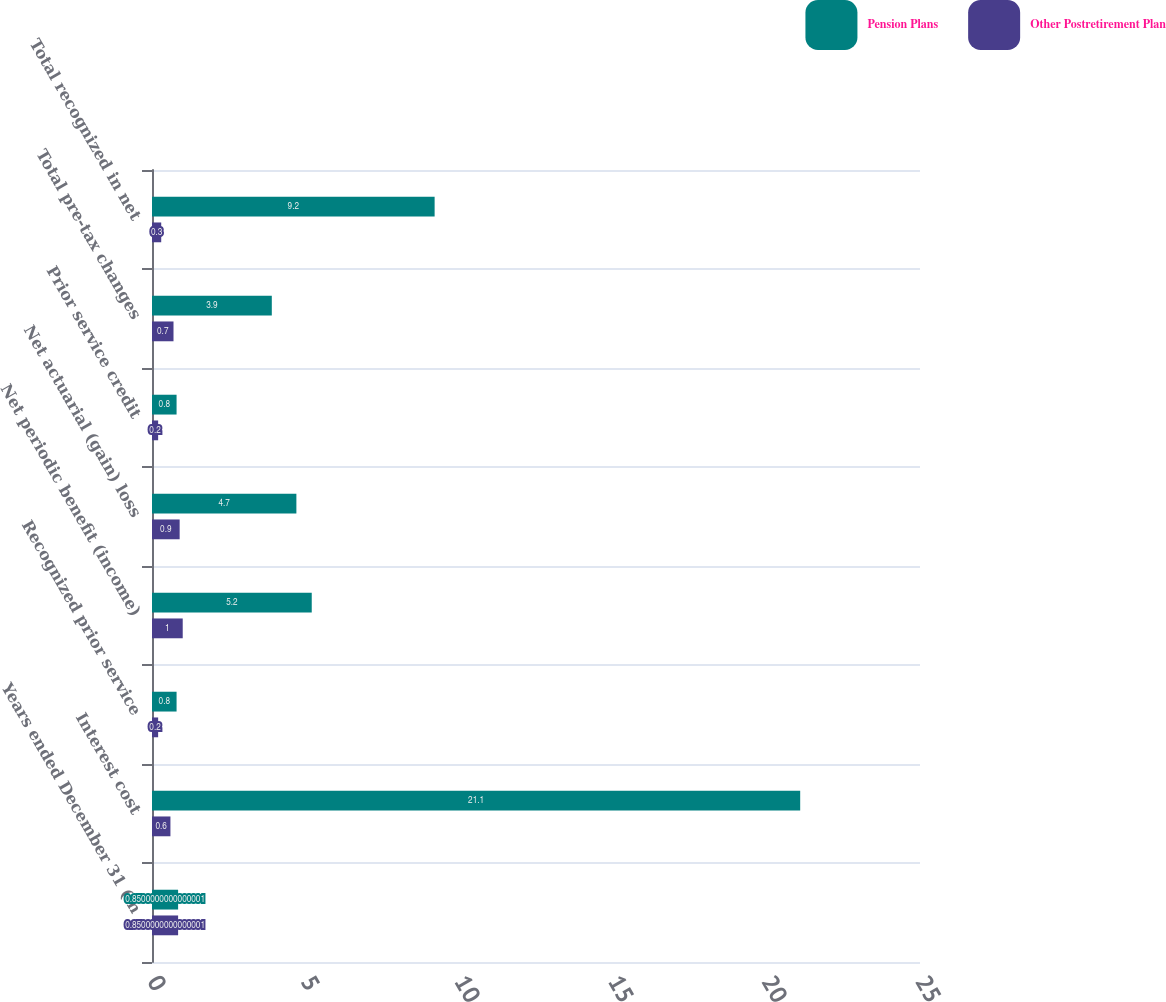Convert chart to OTSL. <chart><loc_0><loc_0><loc_500><loc_500><stacked_bar_chart><ecel><fcel>Years ended December 31 (in<fcel>Interest cost<fcel>Recognized prior service<fcel>Net periodic benefit (income)<fcel>Net actuarial (gain) loss<fcel>Prior service credit<fcel>Total pre-tax changes<fcel>Total recognized in net<nl><fcel>Pension Plans<fcel>0.85<fcel>21.1<fcel>0.8<fcel>5.2<fcel>4.7<fcel>0.8<fcel>3.9<fcel>9.2<nl><fcel>Other Postretirement Plan<fcel>0.85<fcel>0.6<fcel>0.2<fcel>1<fcel>0.9<fcel>0.2<fcel>0.7<fcel>0.3<nl></chart> 